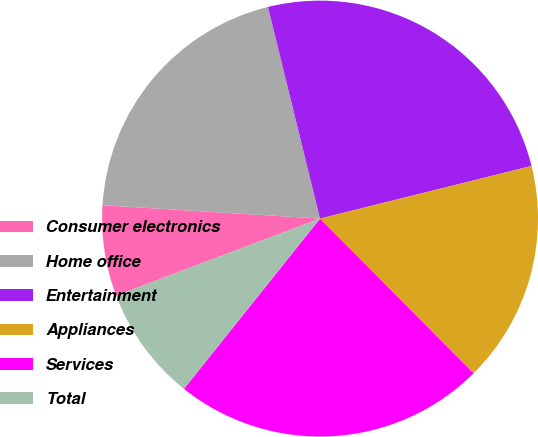Convert chart to OTSL. <chart><loc_0><loc_0><loc_500><loc_500><pie_chart><fcel>Consumer electronics<fcel>Home office<fcel>Entertainment<fcel>Appliances<fcel>Services<fcel>Total<nl><fcel>6.73%<fcel>20.18%<fcel>24.96%<fcel>16.44%<fcel>23.17%<fcel>8.52%<nl></chart> 